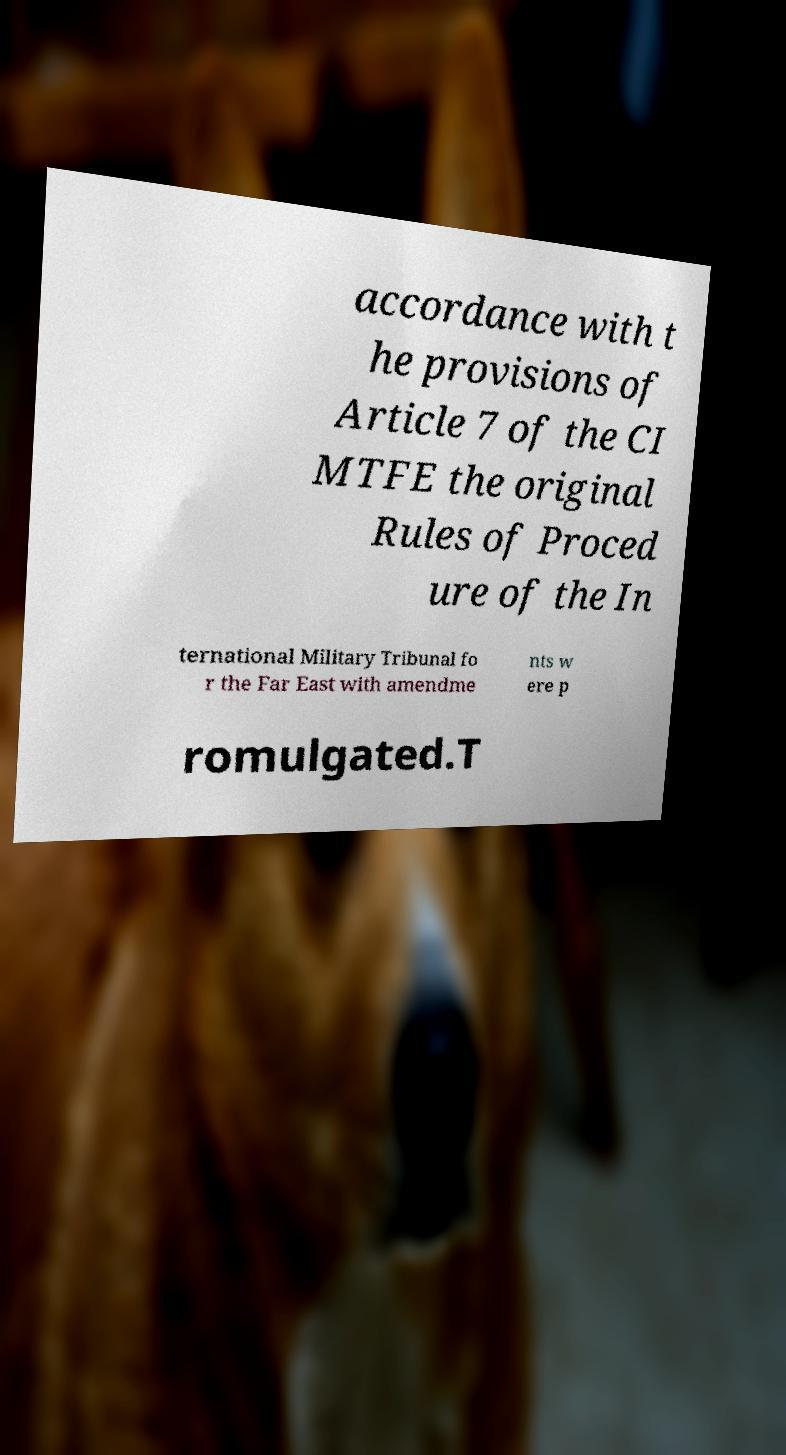For documentation purposes, I need the text within this image transcribed. Could you provide that? accordance with t he provisions of Article 7 of the CI MTFE the original Rules of Proced ure of the In ternational Military Tribunal fo r the Far East with amendme nts w ere p romulgated.T 